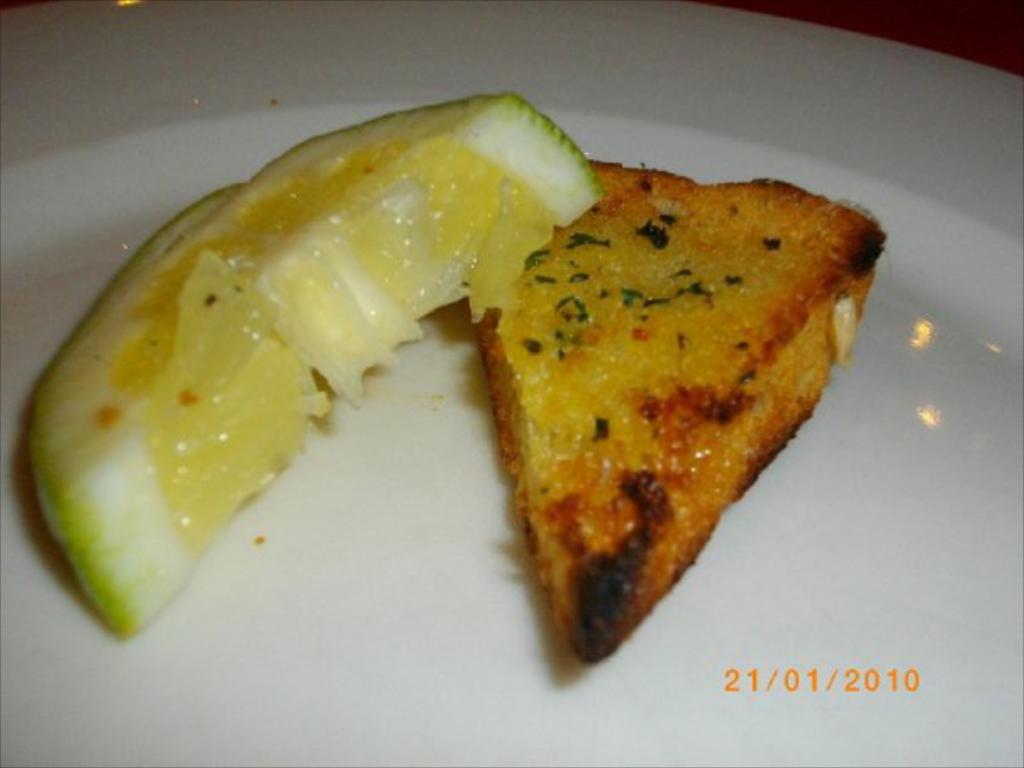Can you describe this image briefly? It is a lemon piece in the left side and in the right side it is a bread piece in a white color plate. 